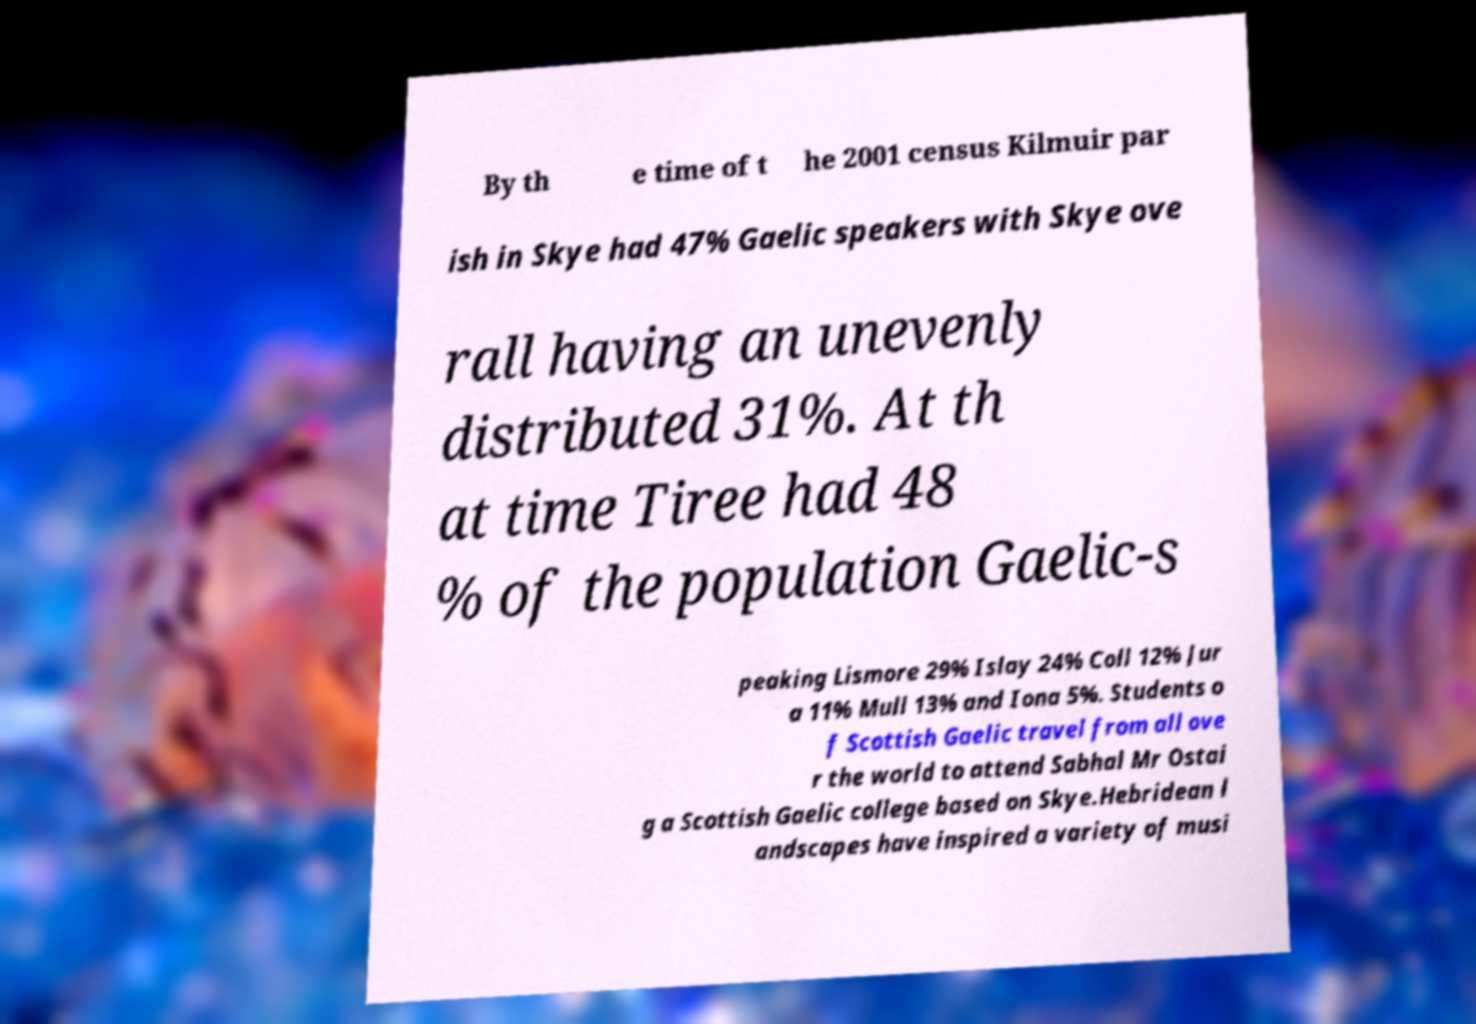For documentation purposes, I need the text within this image transcribed. Could you provide that? By th e time of t he 2001 census Kilmuir par ish in Skye had 47% Gaelic speakers with Skye ove rall having an unevenly distributed 31%. At th at time Tiree had 48 % of the population Gaelic-s peaking Lismore 29% Islay 24% Coll 12% Jur a 11% Mull 13% and Iona 5%. Students o f Scottish Gaelic travel from all ove r the world to attend Sabhal Mr Ostai g a Scottish Gaelic college based on Skye.Hebridean l andscapes have inspired a variety of musi 